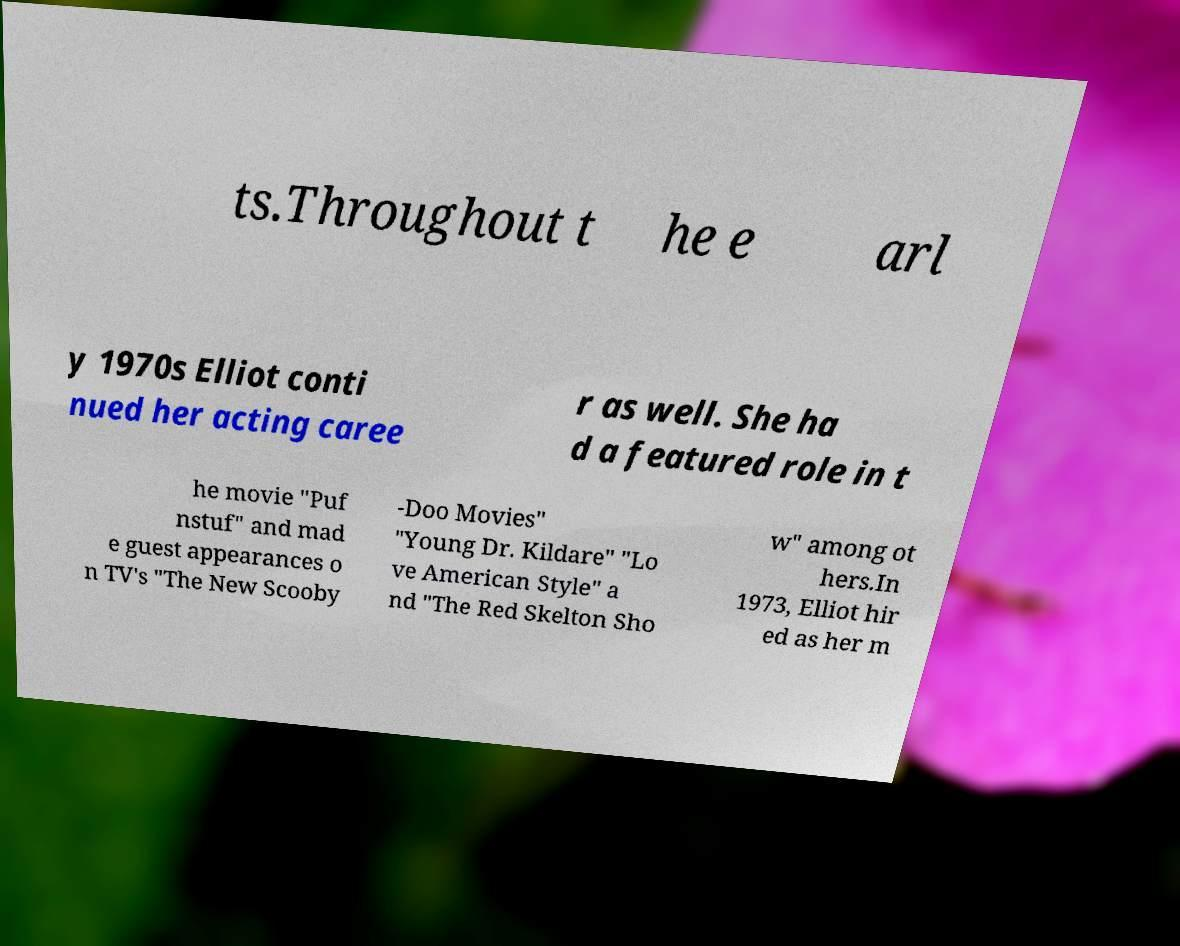For documentation purposes, I need the text within this image transcribed. Could you provide that? ts.Throughout t he e arl y 1970s Elliot conti nued her acting caree r as well. She ha d a featured role in t he movie "Puf nstuf" and mad e guest appearances o n TV's "The New Scooby -Doo Movies" "Young Dr. Kildare" "Lo ve American Style" a nd "The Red Skelton Sho w" among ot hers.In 1973, Elliot hir ed as her m 